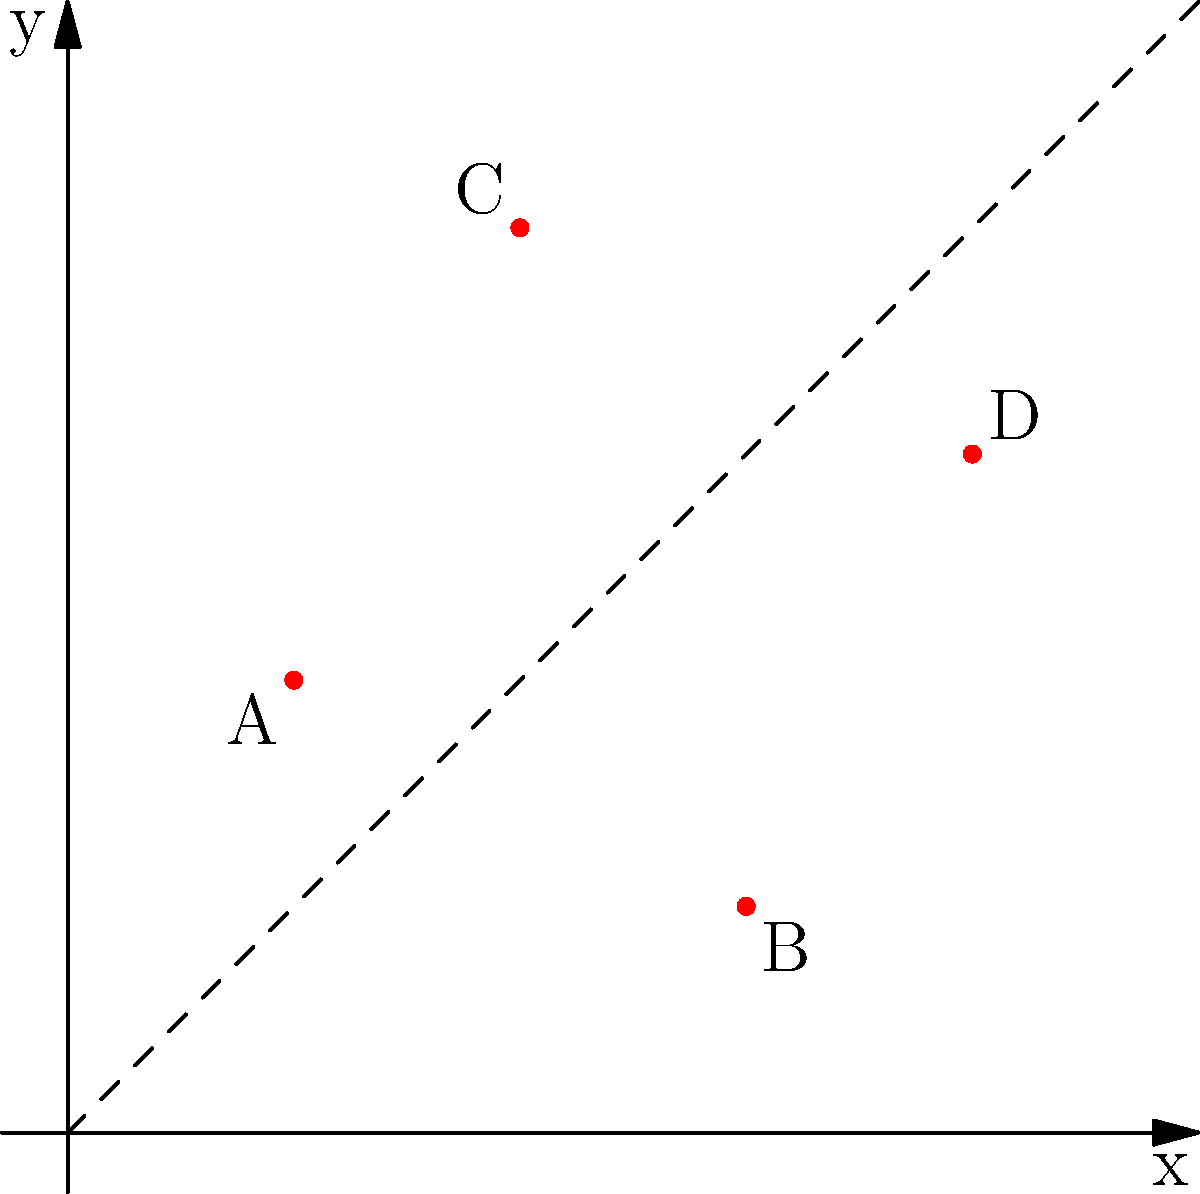As a financial coach, you're planning free workshops in different locations. The graph shows the locations of four workshops (A, B, C, D) on a 2D grid representing a city map. The dashed line represents the city's main street. Which workshop location is furthest from the main street? To determine which workshop location is furthest from the main street, we need to follow these steps:

1. Understand that the dashed line $y=x$ represents the main street.
2. Calculate the perpendicular distance from each point to the line $y=x$.
3. The formula for the distance $d$ of a point $(x_0, y_0)$ from the line $y=x$ is:

   $$d = \frac{|y_0 - x_0|}{\sqrt{2}}$$

4. Calculate the distance for each point:
   
   A(1,2): $d_A = \frac{|2-1|}{\sqrt{2}} = \frac{1}{\sqrt{2}} \approx 0.71$
   
   B(3,1): $d_B = \frac{|1-3|}{\sqrt{2}} = \frac{2}{\sqrt{2}} \approx 1.41$
   
   C(2,4): $d_C = \frac{|4-2|}{\sqrt{2}} = \frac{2}{\sqrt{2}} \approx 1.41$
   
   D(4,3): $d_D = \frac{|3-4|}{\sqrt{2}} = \frac{1}{\sqrt{2}} \approx 0.71$

5. Compare the distances. Both B and C have the largest distance of $\frac{2}{\sqrt{2}}$.

6. Since there are two points with the same maximum distance, we choose the one that appears later alphabetically.
Answer: C 